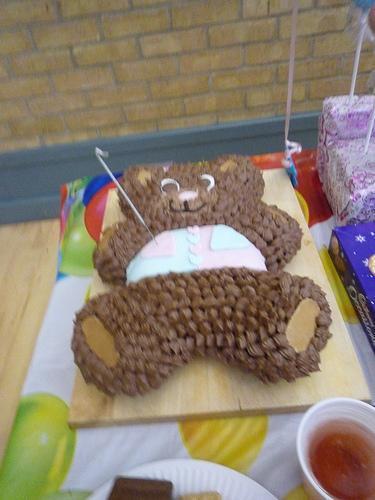How many bears are visible?
Give a very brief answer. 1. How many buttons are on the bears vest?
Give a very brief answer. 4. 